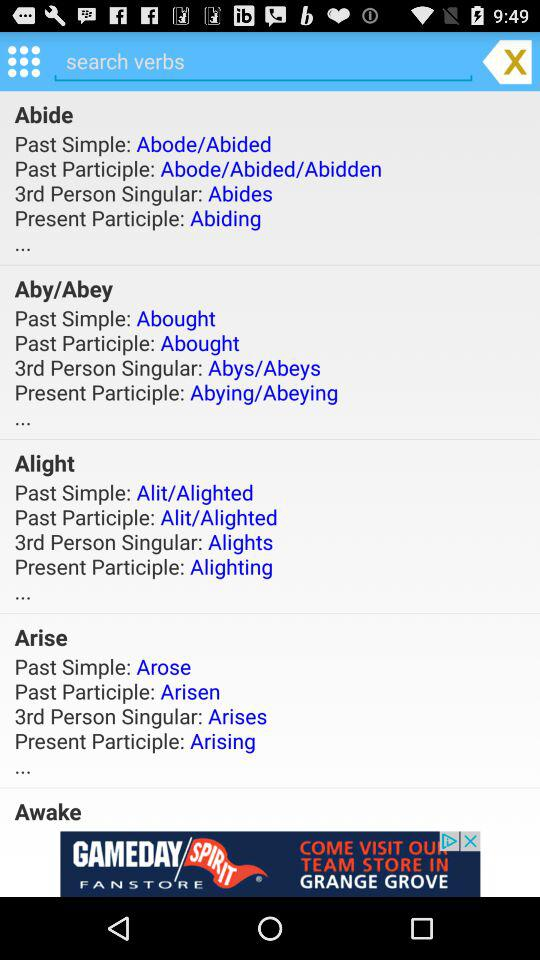What is Aby's Present Participle? Aby's Present Participle is Abying/Abeying. 